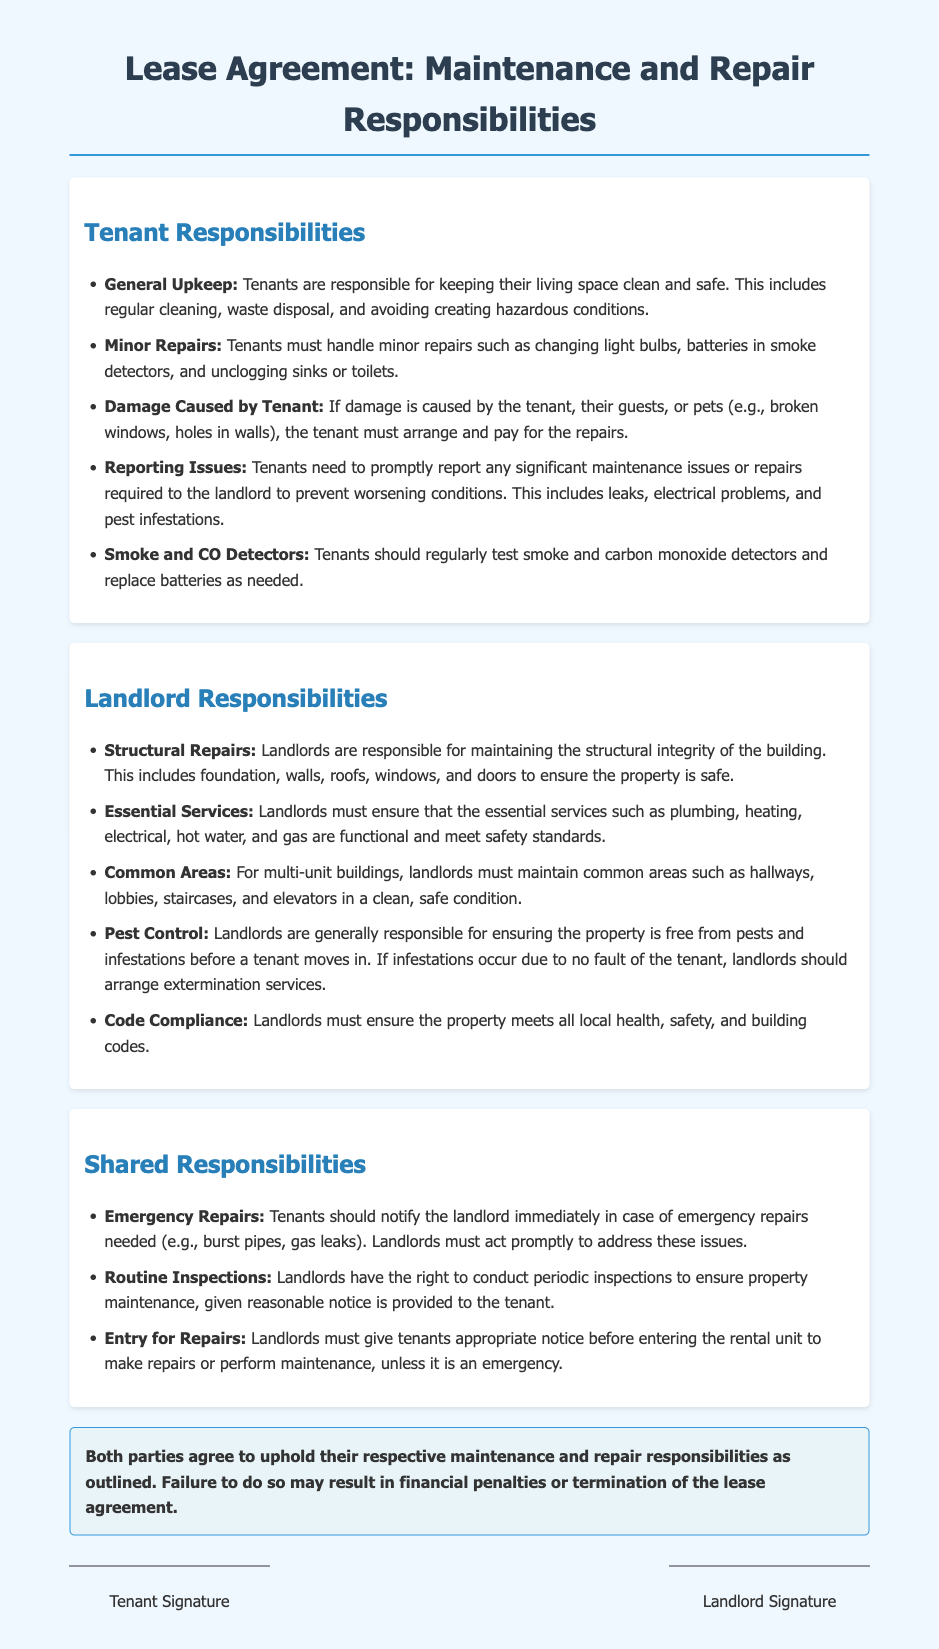What are the tenant's responsibilities? The tenant's responsibilities are outlined in a section of the document that lists specific duties related to maintenance and repairs.
Answer: General upkeep, minor repairs, damage caused by tenant, reporting issues, smoke and CO detectors What must landlords ensure regarding essential services? The document specifies that landlords are responsible for maintaining essential services in the property, which include plumbing, heating, electrical, hot water, and gas.
Answer: Functional What is required from tenants in case of emergency repairs? The document indicates that tenants must notify the landlord immediately if emergency repairs are needed.
Answer: Notify immediately Who is responsible for pest control before a tenant moves in? There is a specific mention of responsibilities regarding pest control, which outlines landlords' responsibilities before a tenant's move-in.
Answer: Landlords What should landlords do before conducting inspections? The document mentions the need for landlords to provide reasonable notice to tenants before inspections are conducted.
Answer: Reasonable notice What happens if either party fails to uphold responsibilities? The document clearly states the consequences that arise from not adhering to maintenance and repair responsibilities.
Answer: Financial penalties or termination of the lease agreement 